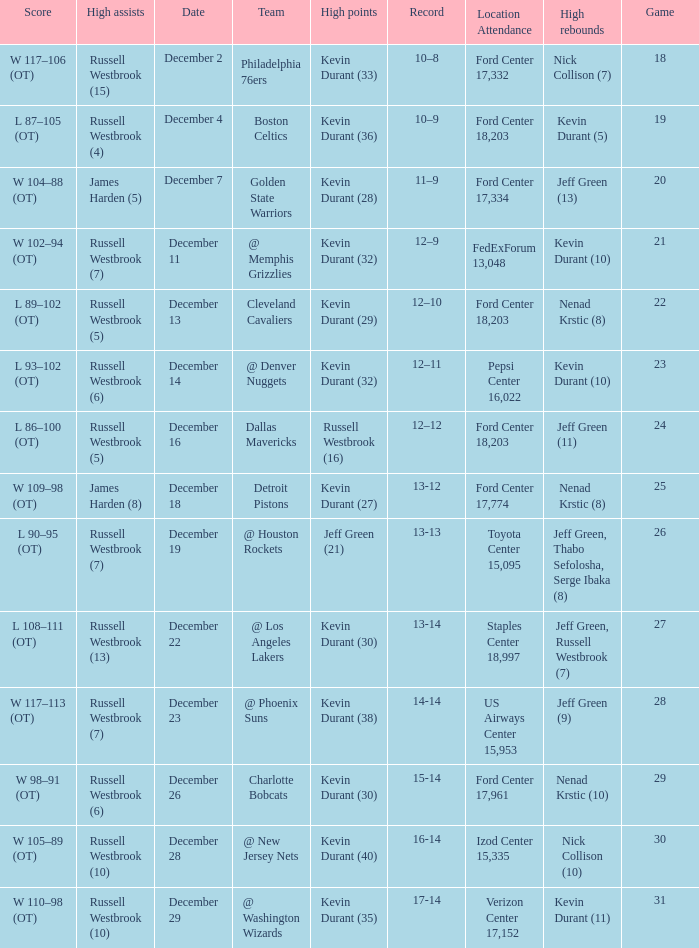What is the score for the date of December 7? W 104–88 (OT). 